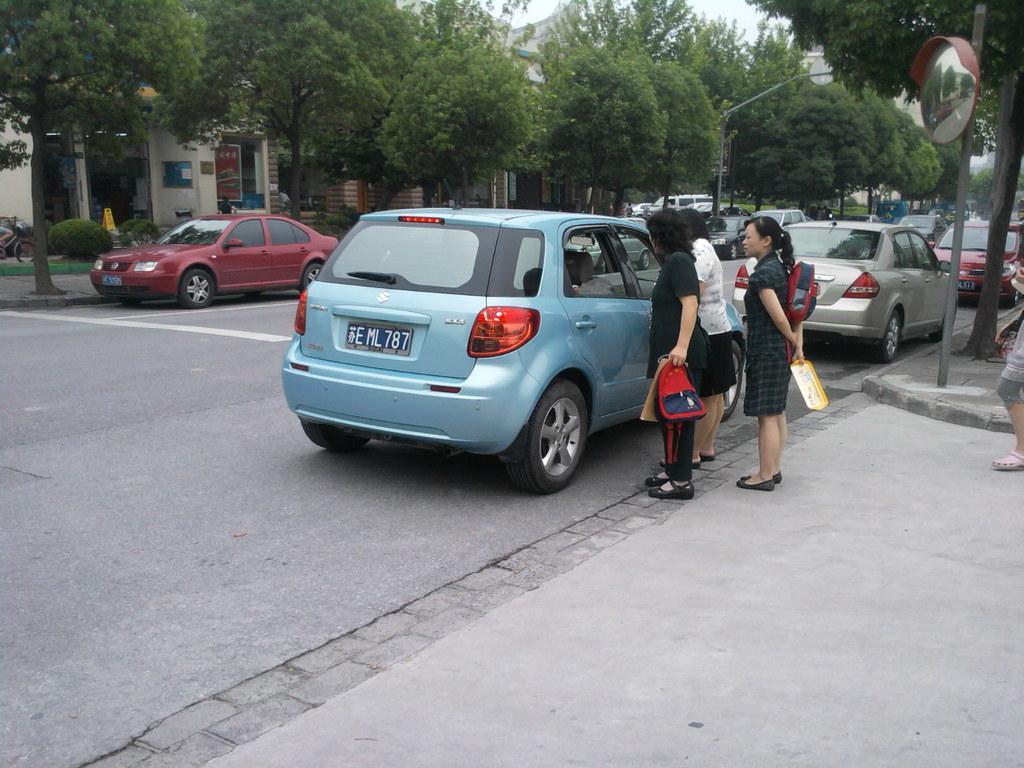Please provide a concise description of this image. In this image there are cars parked on the road. Beside the blue car three women standing. At the background there are buildings and trees. 